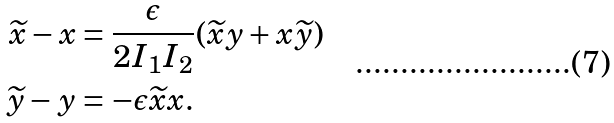<formula> <loc_0><loc_0><loc_500><loc_500>\widetilde { x } - x & = \frac { \epsilon } { 2 I _ { 1 } I _ { 2 } } ( \widetilde { x } y + x \widetilde { y } ) \\ \widetilde { y } - y & = - \epsilon \widetilde { x } x .</formula> 